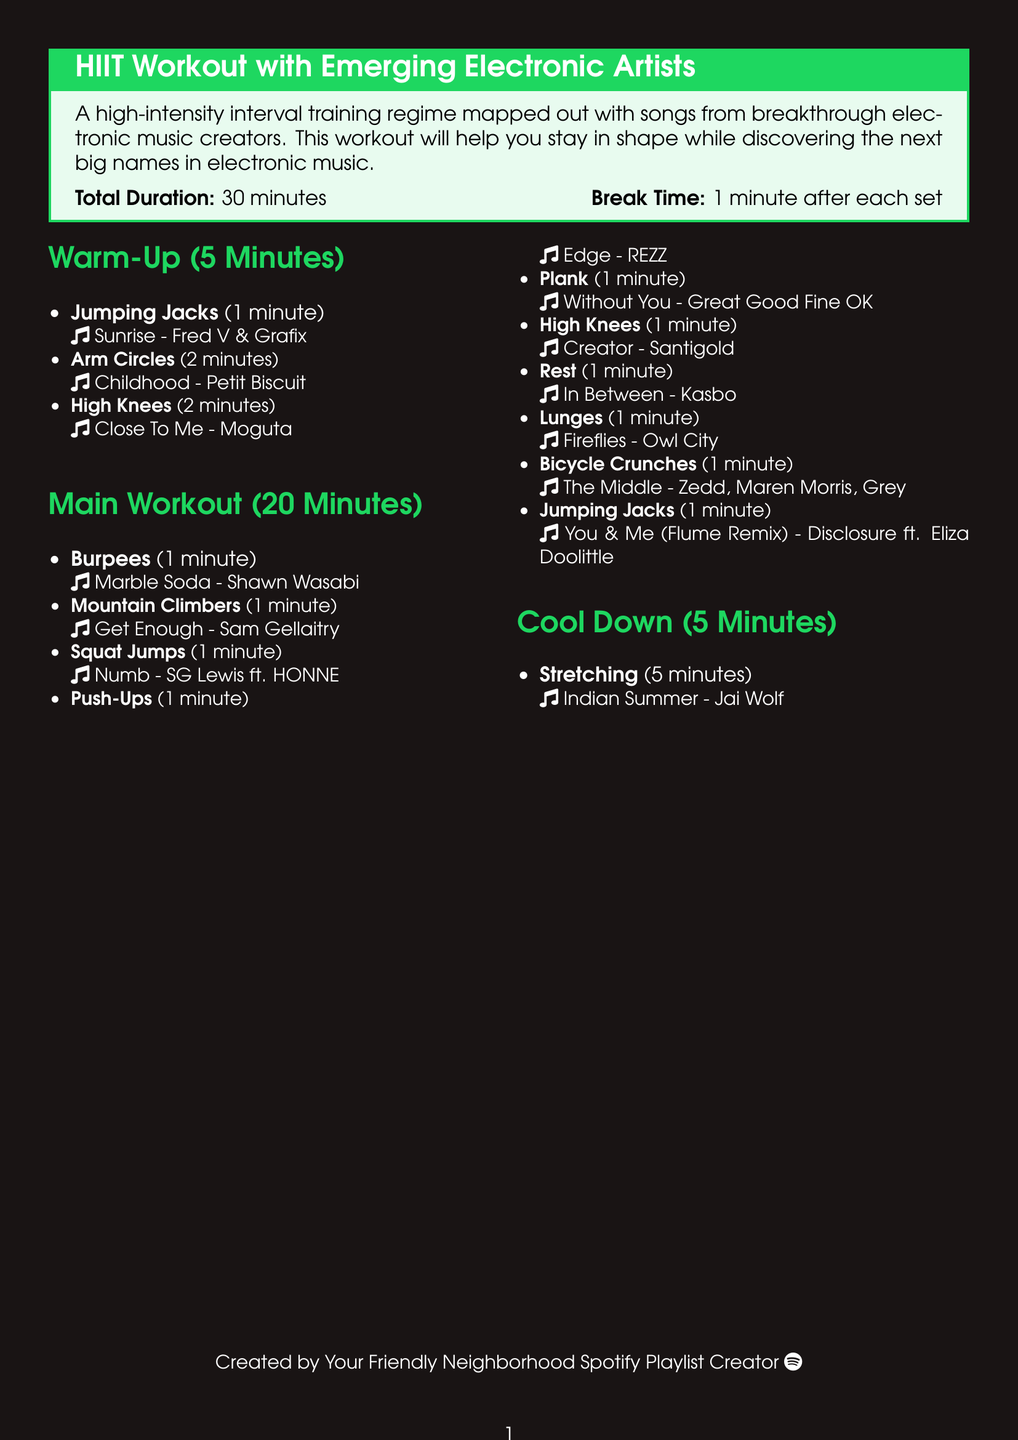What is the total duration of the workout? The total duration is clearly stated at the beginning of the workout plan, listed as 30 minutes.
Answer: 30 minutes Which exercise is paired with the song "Marble Soda"? The song "Marble Soda" appears next to the exercise "Burpees" in the main workout section.
Answer: Burpees How long should one rest after each set? The break time after each set is specified as being 1 minute.
Answer: 1 minute What is the last exercise in the cool down section? The last exercise listed in the cool down section is "Stretching", which completes the workout routine.
Answer: Stretching Which artist is featured in the song for Jumping Jacks? The song "Sunrise" is attributed to artists Fred V & Grafix for the Jumping Jacks exercise.
Answer: Fred V & Grafix How many exercises are included in the main workout? By counting the items listed, there are 10 exercises in the main workout section.
Answer: 10 What is the song corresponding to the exercise "Plank"? The exercise "Plank" is matched with the song "Without You" by Great Good Fine OK.
Answer: Without You - Great Good Fine OK Which exercise is performed just before the rest period? The exercise performed before the rest period is "High Knees", as indicated in the workout plan.
Answer: High Knees 